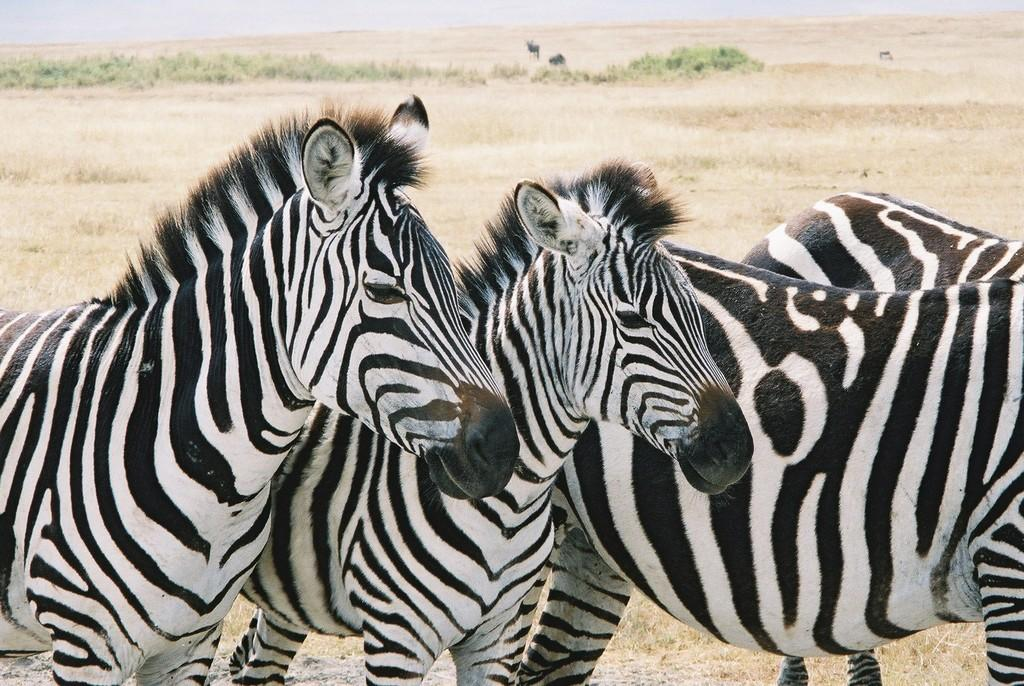How many zebras are present in the image? There are 4 zebras in the image. Where are the zebras located in relation to the image? The zebras are in the foreground of the image. What can be seen in the background of the image? There is grass and plants visible in the background of the image. Are there any other animals visible in the image? Yes, there are other animals visible in the background. What type of cemetery can be seen in the background of the image? There is no cemetery present in the image; it features zebras in the foreground and grass and plants in the background. Can you tell me the name of the zebras' partner in the image? There is no mention of a partner for the zebras in the image, as they are the main focus. 